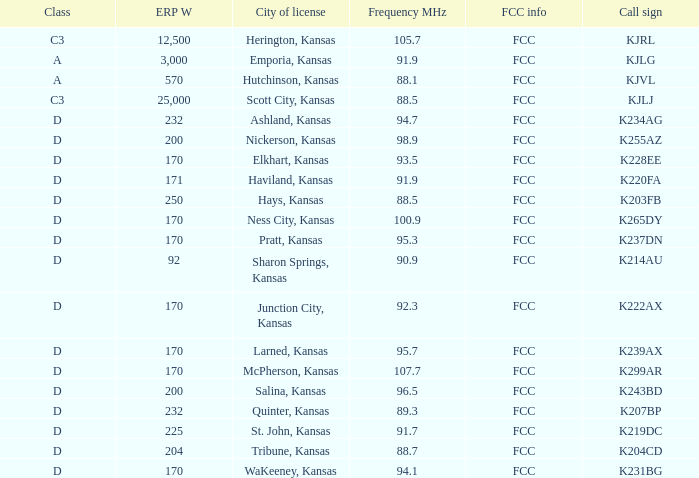Frequency MHz of 88.7 had what average erp w? 204.0. 